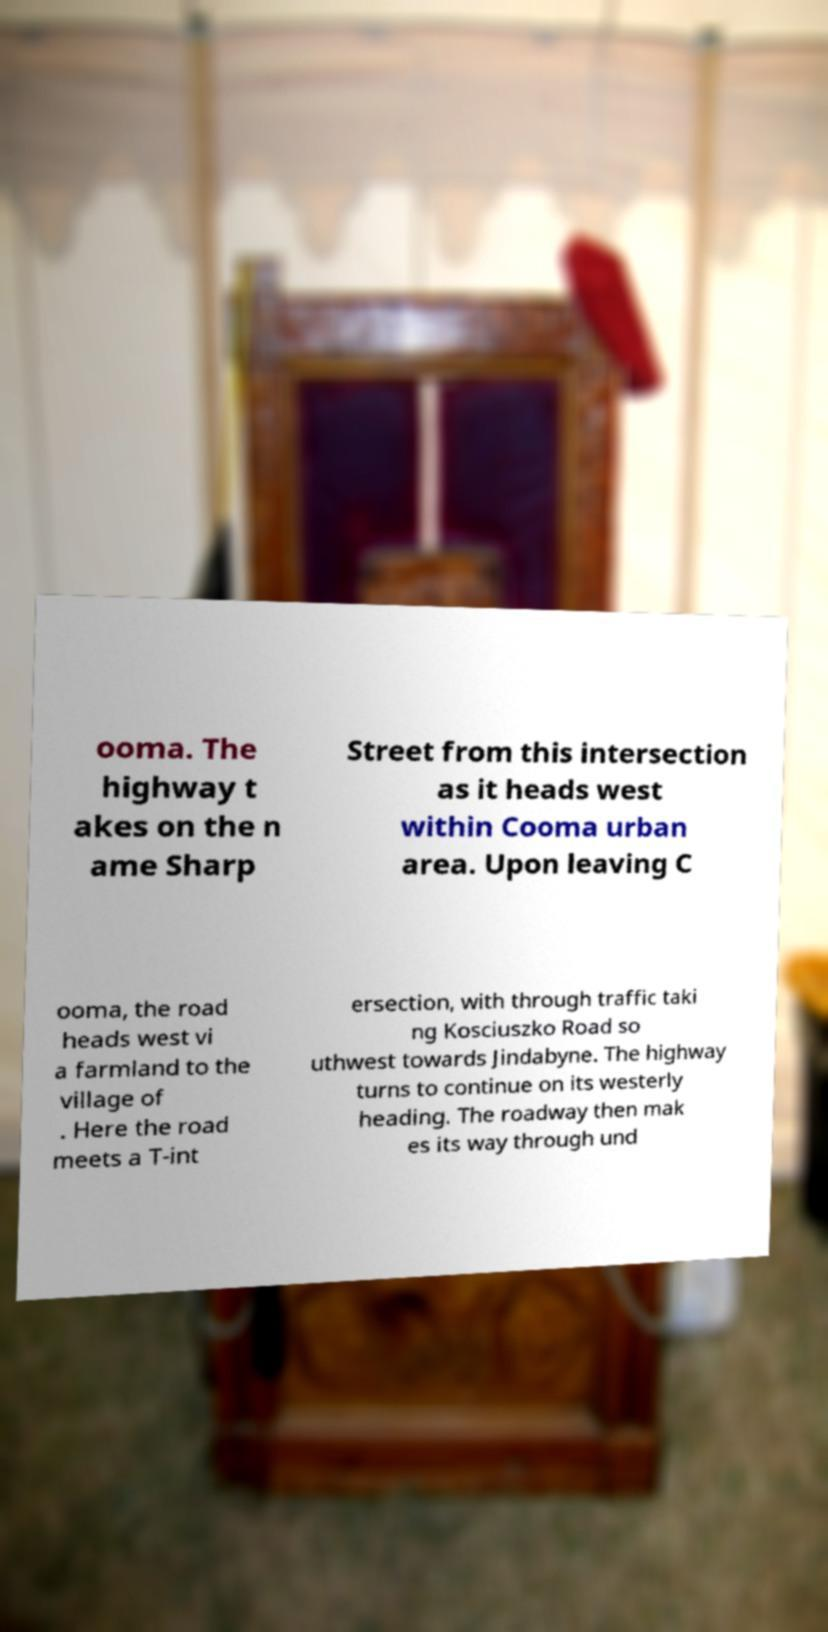Please identify and transcribe the text found in this image. ooma. The highway t akes on the n ame Sharp Street from this intersection as it heads west within Cooma urban area. Upon leaving C ooma, the road heads west vi a farmland to the village of . Here the road meets a T-int ersection, with through traffic taki ng Kosciuszko Road so uthwest towards Jindabyne. The highway turns to continue on its westerly heading. The roadway then mak es its way through und 